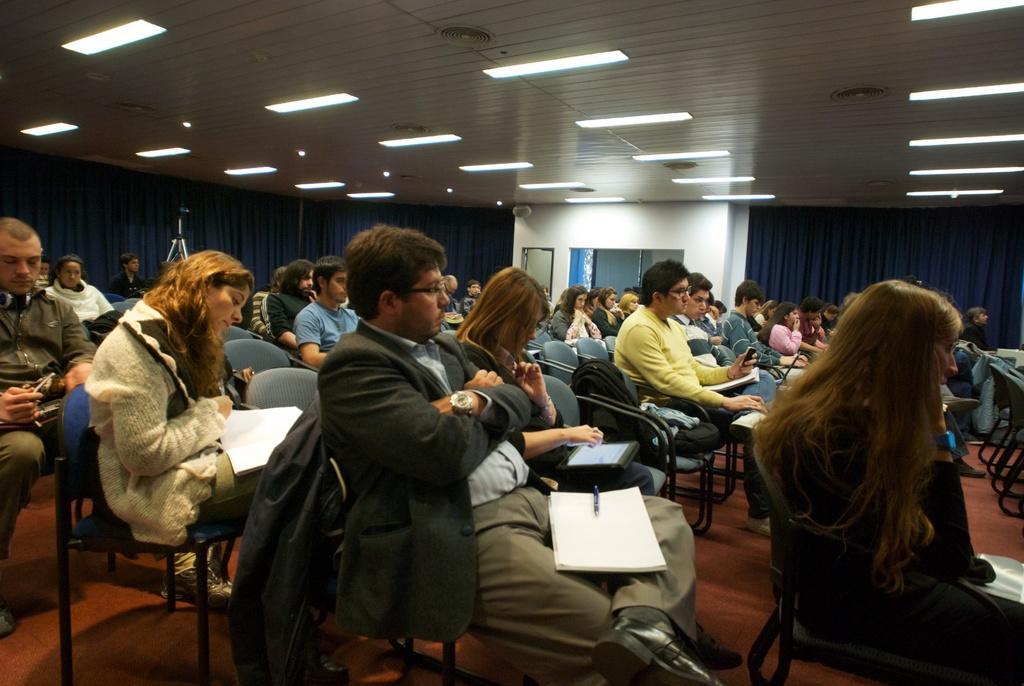Can you describe this image briefly? The picture is taken in a big hall where number of people are sitting on the chairs, in the middle of the picture the person is sitting and kept the book on his lap, beside him a woman is seeing a tab and behind him a girl is wearing a coat and seeing a book and behind the people there is a blue curtain and there is a wall with a door and there are lights on the roof. 